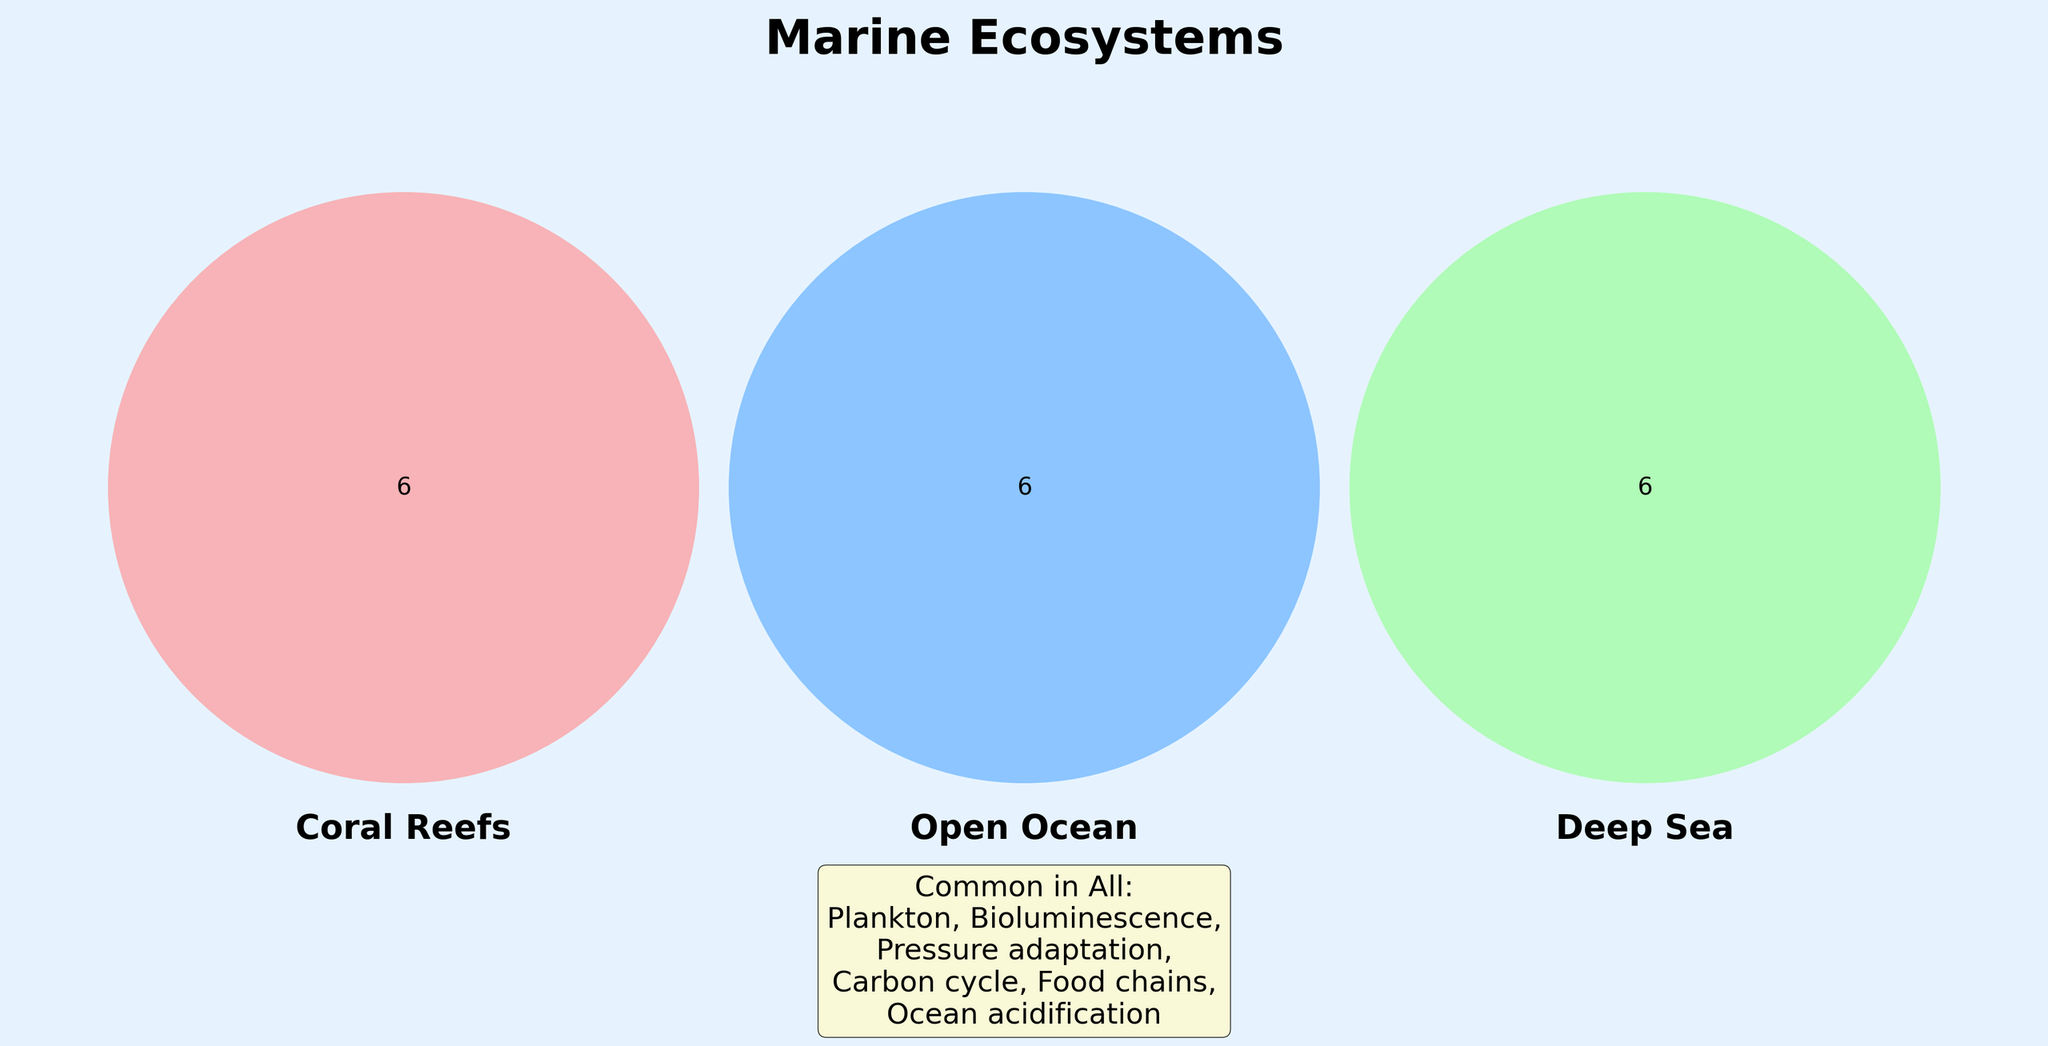What is the title of the figure? The title is written at the top of the figure in bold and large font.
Answer: Marine Ecosystems What is common among all three ecosystems? The annotation at the bottom of the figure lists elements common to all.
Answer: Plankton, Bioluminescence, Pressure adaptation, Carbon cycle, Food chains, Ocean acidification Which organisms are unique to the Coral Reefs ecosystem? Coral Reefs are indicated by the red color and inside it are organisms unique to this ecosystem.
Answer: Parrotfish, Staghorn coral, Clownfish, Sea urchins, Algae symbiosis, Coral bleaching What organisms do Coral Reefs and Open Ocean share? The overlapping section between Coral Reefs (red) and Open Ocean (blue) shows shared organisms.
Answer: (None listed in data) Which two ecosystems share the Hydrothermal vents? Look at the green section overlapping with another color; Hydrothermal vents are unique to Deep Sea (green)
Answer: Deep Sea and Open Ocean How many elements are unique to the Deep Sea ecosystem? Count the elements in the green section that doesn't overlap with any other color.
Answer: 6 What is the common element between Deep Sea and Open Ocean but not shared with Coral Reefs? Look at the intersection between Deep Sea (green) and Open Ocean (blue) sections without touching the Coral Reefs (red).
Answer: (None listed in data) Which specific adaptation is shared across all marine ecosystems? Refer to common elements in the annotation at the bottom that are adaptations.
Answer: Pressure adaptation How many elements total are listed in the figure? Add up all the unique and shared elements across all sections.
Answer: 24 